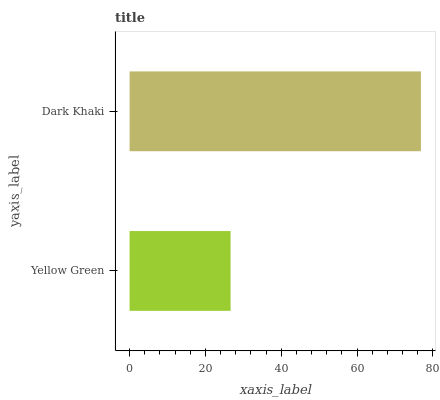Is Yellow Green the minimum?
Answer yes or no. Yes. Is Dark Khaki the maximum?
Answer yes or no. Yes. Is Dark Khaki the minimum?
Answer yes or no. No. Is Dark Khaki greater than Yellow Green?
Answer yes or no. Yes. Is Yellow Green less than Dark Khaki?
Answer yes or no. Yes. Is Yellow Green greater than Dark Khaki?
Answer yes or no. No. Is Dark Khaki less than Yellow Green?
Answer yes or no. No. Is Dark Khaki the high median?
Answer yes or no. Yes. Is Yellow Green the low median?
Answer yes or no. Yes. Is Yellow Green the high median?
Answer yes or no. No. Is Dark Khaki the low median?
Answer yes or no. No. 